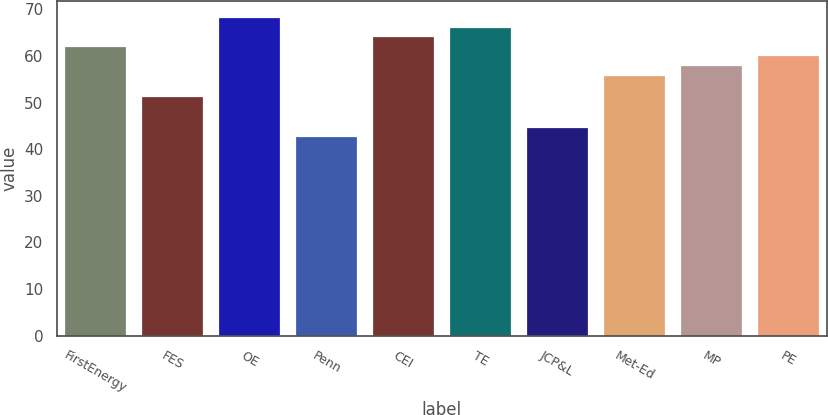Convert chart to OTSL. <chart><loc_0><loc_0><loc_500><loc_500><bar_chart><fcel>FirstEnergy<fcel>FES<fcel>OE<fcel>Penn<fcel>CEI<fcel>TE<fcel>JCP&L<fcel>Met-Ed<fcel>MP<fcel>PE<nl><fcel>62.18<fcel>51.4<fcel>68.36<fcel>42.8<fcel>64.24<fcel>66.3<fcel>44.86<fcel>56<fcel>58.06<fcel>60.12<nl></chart> 